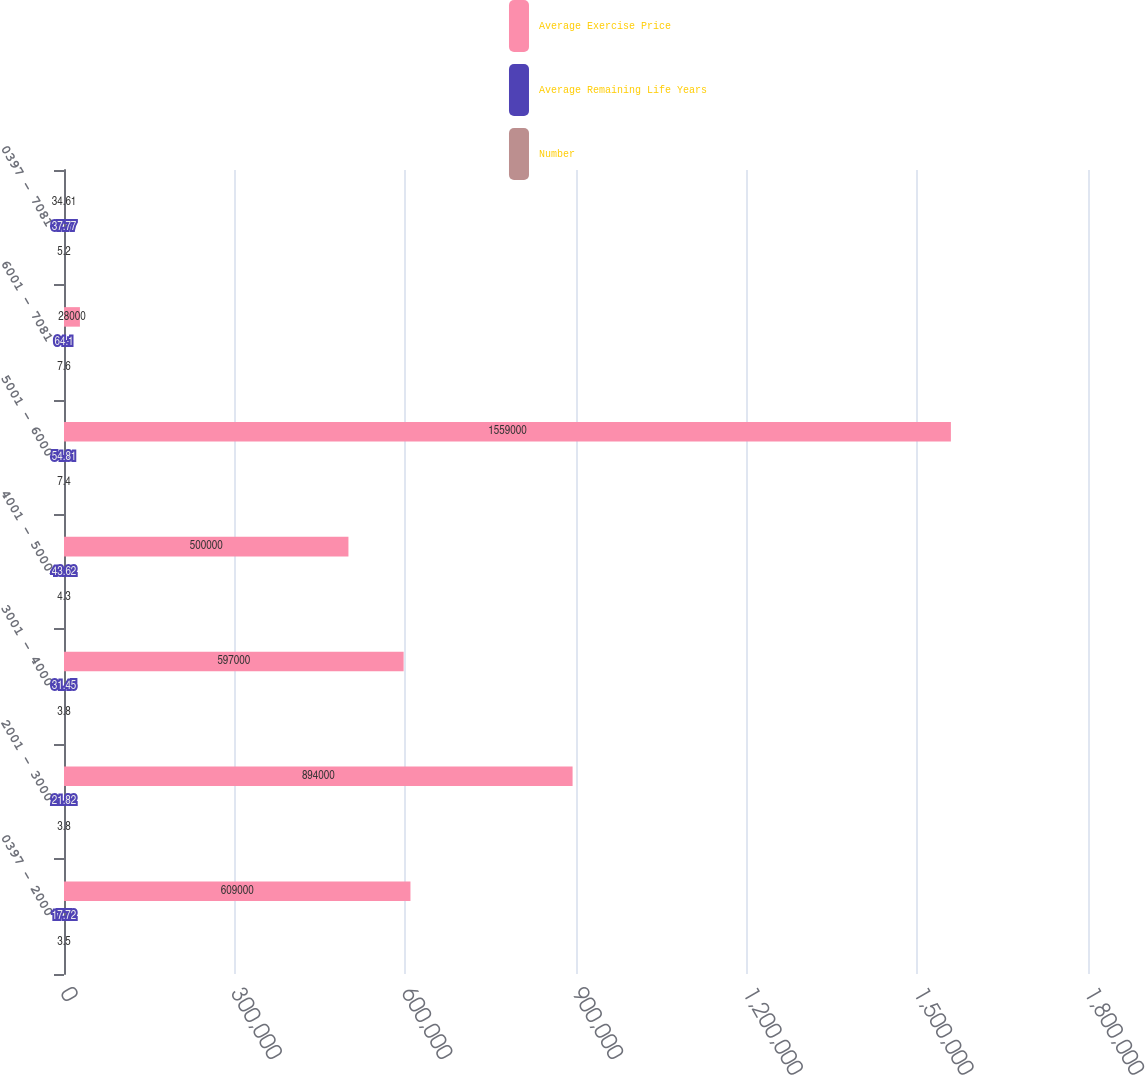<chart> <loc_0><loc_0><loc_500><loc_500><stacked_bar_chart><ecel><fcel>0397 - 2000<fcel>2001 - 3000<fcel>3001 - 4000<fcel>4001 - 5000<fcel>5001 - 6000<fcel>6001 - 7081<fcel>0397 - 7081<nl><fcel>Average Exercise Price<fcel>609000<fcel>894000<fcel>597000<fcel>500000<fcel>1.559e+06<fcel>28000<fcel>34.61<nl><fcel>Average Remaining Life Years<fcel>17.72<fcel>21.82<fcel>31.45<fcel>43.62<fcel>54.81<fcel>64.1<fcel>37.77<nl><fcel>Number<fcel>3.5<fcel>3.8<fcel>3.8<fcel>4.3<fcel>7.4<fcel>7.6<fcel>5.2<nl></chart> 